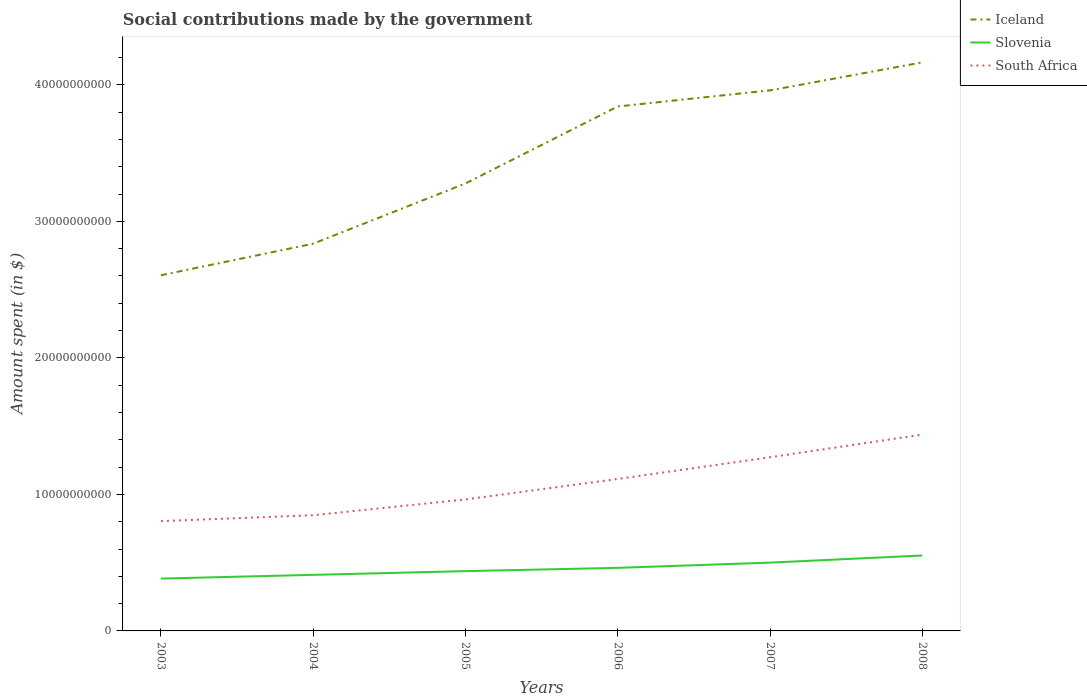Does the line corresponding to Slovenia intersect with the line corresponding to Iceland?
Make the answer very short. No. Across all years, what is the maximum amount spent on social contributions in Slovenia?
Provide a succinct answer. 3.83e+09. In which year was the amount spent on social contributions in South Africa maximum?
Keep it short and to the point. 2003. What is the total amount spent on social contributions in Slovenia in the graph?
Offer a terse response. -2.74e+08. What is the difference between the highest and the second highest amount spent on social contributions in Iceland?
Give a very brief answer. 1.56e+1. What is the difference between the highest and the lowest amount spent on social contributions in Iceland?
Give a very brief answer. 3. Is the amount spent on social contributions in Iceland strictly greater than the amount spent on social contributions in South Africa over the years?
Give a very brief answer. No. How many lines are there?
Ensure brevity in your answer.  3. How many years are there in the graph?
Make the answer very short. 6. Are the values on the major ticks of Y-axis written in scientific E-notation?
Your answer should be very brief. No. Does the graph contain any zero values?
Your answer should be very brief. No. How many legend labels are there?
Your answer should be very brief. 3. How are the legend labels stacked?
Provide a short and direct response. Vertical. What is the title of the graph?
Offer a very short reply. Social contributions made by the government. What is the label or title of the Y-axis?
Provide a succinct answer. Amount spent (in $). What is the Amount spent (in $) in Iceland in 2003?
Your response must be concise. 2.61e+1. What is the Amount spent (in $) of Slovenia in 2003?
Provide a short and direct response. 3.83e+09. What is the Amount spent (in $) in South Africa in 2003?
Offer a very short reply. 8.04e+09. What is the Amount spent (in $) of Iceland in 2004?
Make the answer very short. 2.84e+1. What is the Amount spent (in $) of Slovenia in 2004?
Give a very brief answer. 4.11e+09. What is the Amount spent (in $) in South Africa in 2004?
Your answer should be compact. 8.47e+09. What is the Amount spent (in $) in Iceland in 2005?
Offer a terse response. 3.28e+1. What is the Amount spent (in $) of Slovenia in 2005?
Your answer should be compact. 4.38e+09. What is the Amount spent (in $) of South Africa in 2005?
Your answer should be compact. 9.63e+09. What is the Amount spent (in $) in Iceland in 2006?
Make the answer very short. 3.84e+1. What is the Amount spent (in $) of Slovenia in 2006?
Ensure brevity in your answer.  4.62e+09. What is the Amount spent (in $) in South Africa in 2006?
Give a very brief answer. 1.11e+1. What is the Amount spent (in $) of Iceland in 2007?
Your answer should be compact. 3.96e+1. What is the Amount spent (in $) in Slovenia in 2007?
Offer a terse response. 5.00e+09. What is the Amount spent (in $) of South Africa in 2007?
Provide a succinct answer. 1.27e+1. What is the Amount spent (in $) in Iceland in 2008?
Provide a short and direct response. 4.16e+1. What is the Amount spent (in $) of Slovenia in 2008?
Keep it short and to the point. 5.53e+09. What is the Amount spent (in $) of South Africa in 2008?
Make the answer very short. 1.44e+1. Across all years, what is the maximum Amount spent (in $) of Iceland?
Ensure brevity in your answer.  4.16e+1. Across all years, what is the maximum Amount spent (in $) in Slovenia?
Make the answer very short. 5.53e+09. Across all years, what is the maximum Amount spent (in $) in South Africa?
Offer a very short reply. 1.44e+1. Across all years, what is the minimum Amount spent (in $) of Iceland?
Offer a terse response. 2.61e+1. Across all years, what is the minimum Amount spent (in $) of Slovenia?
Keep it short and to the point. 3.83e+09. Across all years, what is the minimum Amount spent (in $) of South Africa?
Your answer should be very brief. 8.04e+09. What is the total Amount spent (in $) of Iceland in the graph?
Ensure brevity in your answer.  2.07e+11. What is the total Amount spent (in $) of Slovenia in the graph?
Give a very brief answer. 2.75e+1. What is the total Amount spent (in $) in South Africa in the graph?
Ensure brevity in your answer.  6.44e+1. What is the difference between the Amount spent (in $) of Iceland in 2003 and that in 2004?
Make the answer very short. -2.31e+09. What is the difference between the Amount spent (in $) in Slovenia in 2003 and that in 2004?
Provide a short and direct response. -2.74e+08. What is the difference between the Amount spent (in $) of South Africa in 2003 and that in 2004?
Offer a terse response. -4.30e+08. What is the difference between the Amount spent (in $) in Iceland in 2003 and that in 2005?
Provide a short and direct response. -6.72e+09. What is the difference between the Amount spent (in $) of Slovenia in 2003 and that in 2005?
Give a very brief answer. -5.46e+08. What is the difference between the Amount spent (in $) in South Africa in 2003 and that in 2005?
Your response must be concise. -1.59e+09. What is the difference between the Amount spent (in $) in Iceland in 2003 and that in 2006?
Make the answer very short. -1.24e+1. What is the difference between the Amount spent (in $) in Slovenia in 2003 and that in 2006?
Offer a very short reply. -7.86e+08. What is the difference between the Amount spent (in $) in South Africa in 2003 and that in 2006?
Offer a very short reply. -3.09e+09. What is the difference between the Amount spent (in $) of Iceland in 2003 and that in 2007?
Your answer should be very brief. -1.35e+1. What is the difference between the Amount spent (in $) in Slovenia in 2003 and that in 2007?
Provide a succinct answer. -1.17e+09. What is the difference between the Amount spent (in $) in South Africa in 2003 and that in 2007?
Keep it short and to the point. -4.68e+09. What is the difference between the Amount spent (in $) of Iceland in 2003 and that in 2008?
Give a very brief answer. -1.56e+1. What is the difference between the Amount spent (in $) in Slovenia in 2003 and that in 2008?
Your answer should be compact. -1.69e+09. What is the difference between the Amount spent (in $) of South Africa in 2003 and that in 2008?
Provide a short and direct response. -6.34e+09. What is the difference between the Amount spent (in $) of Iceland in 2004 and that in 2005?
Offer a terse response. -4.41e+09. What is the difference between the Amount spent (in $) in Slovenia in 2004 and that in 2005?
Your answer should be compact. -2.72e+08. What is the difference between the Amount spent (in $) of South Africa in 2004 and that in 2005?
Ensure brevity in your answer.  -1.16e+09. What is the difference between the Amount spent (in $) in Iceland in 2004 and that in 2006?
Offer a very short reply. -1.01e+1. What is the difference between the Amount spent (in $) of Slovenia in 2004 and that in 2006?
Provide a short and direct response. -5.12e+08. What is the difference between the Amount spent (in $) of South Africa in 2004 and that in 2006?
Give a very brief answer. -2.66e+09. What is the difference between the Amount spent (in $) in Iceland in 2004 and that in 2007?
Ensure brevity in your answer.  -1.12e+1. What is the difference between the Amount spent (in $) in Slovenia in 2004 and that in 2007?
Ensure brevity in your answer.  -8.94e+08. What is the difference between the Amount spent (in $) of South Africa in 2004 and that in 2007?
Give a very brief answer. -4.25e+09. What is the difference between the Amount spent (in $) in Iceland in 2004 and that in 2008?
Provide a short and direct response. -1.33e+1. What is the difference between the Amount spent (in $) in Slovenia in 2004 and that in 2008?
Offer a terse response. -1.42e+09. What is the difference between the Amount spent (in $) in South Africa in 2004 and that in 2008?
Your response must be concise. -5.91e+09. What is the difference between the Amount spent (in $) of Iceland in 2005 and that in 2006?
Give a very brief answer. -5.64e+09. What is the difference between the Amount spent (in $) of Slovenia in 2005 and that in 2006?
Your answer should be very brief. -2.40e+08. What is the difference between the Amount spent (in $) in South Africa in 2005 and that in 2006?
Provide a short and direct response. -1.50e+09. What is the difference between the Amount spent (in $) of Iceland in 2005 and that in 2007?
Offer a very short reply. -6.82e+09. What is the difference between the Amount spent (in $) in Slovenia in 2005 and that in 2007?
Provide a succinct answer. -6.22e+08. What is the difference between the Amount spent (in $) in South Africa in 2005 and that in 2007?
Give a very brief answer. -3.09e+09. What is the difference between the Amount spent (in $) in Iceland in 2005 and that in 2008?
Offer a terse response. -8.87e+09. What is the difference between the Amount spent (in $) of Slovenia in 2005 and that in 2008?
Make the answer very short. -1.15e+09. What is the difference between the Amount spent (in $) in South Africa in 2005 and that in 2008?
Provide a short and direct response. -4.75e+09. What is the difference between the Amount spent (in $) of Iceland in 2006 and that in 2007?
Ensure brevity in your answer.  -1.18e+09. What is the difference between the Amount spent (in $) of Slovenia in 2006 and that in 2007?
Your response must be concise. -3.82e+08. What is the difference between the Amount spent (in $) of South Africa in 2006 and that in 2007?
Give a very brief answer. -1.59e+09. What is the difference between the Amount spent (in $) of Iceland in 2006 and that in 2008?
Your answer should be compact. -3.23e+09. What is the difference between the Amount spent (in $) in Slovenia in 2006 and that in 2008?
Provide a succinct answer. -9.06e+08. What is the difference between the Amount spent (in $) in South Africa in 2006 and that in 2008?
Your answer should be very brief. -3.25e+09. What is the difference between the Amount spent (in $) of Iceland in 2007 and that in 2008?
Offer a terse response. -2.05e+09. What is the difference between the Amount spent (in $) in Slovenia in 2007 and that in 2008?
Give a very brief answer. -5.23e+08. What is the difference between the Amount spent (in $) in South Africa in 2007 and that in 2008?
Your answer should be very brief. -1.66e+09. What is the difference between the Amount spent (in $) in Iceland in 2003 and the Amount spent (in $) in Slovenia in 2004?
Your response must be concise. 2.19e+1. What is the difference between the Amount spent (in $) in Iceland in 2003 and the Amount spent (in $) in South Africa in 2004?
Offer a terse response. 1.76e+1. What is the difference between the Amount spent (in $) in Slovenia in 2003 and the Amount spent (in $) in South Africa in 2004?
Your response must be concise. -4.64e+09. What is the difference between the Amount spent (in $) of Iceland in 2003 and the Amount spent (in $) of Slovenia in 2005?
Your response must be concise. 2.17e+1. What is the difference between the Amount spent (in $) in Iceland in 2003 and the Amount spent (in $) in South Africa in 2005?
Offer a terse response. 1.64e+1. What is the difference between the Amount spent (in $) of Slovenia in 2003 and the Amount spent (in $) of South Africa in 2005?
Your answer should be compact. -5.80e+09. What is the difference between the Amount spent (in $) of Iceland in 2003 and the Amount spent (in $) of Slovenia in 2006?
Offer a very short reply. 2.14e+1. What is the difference between the Amount spent (in $) of Iceland in 2003 and the Amount spent (in $) of South Africa in 2006?
Your response must be concise. 1.49e+1. What is the difference between the Amount spent (in $) in Slovenia in 2003 and the Amount spent (in $) in South Africa in 2006?
Ensure brevity in your answer.  -7.30e+09. What is the difference between the Amount spent (in $) of Iceland in 2003 and the Amount spent (in $) of Slovenia in 2007?
Give a very brief answer. 2.11e+1. What is the difference between the Amount spent (in $) in Iceland in 2003 and the Amount spent (in $) in South Africa in 2007?
Your answer should be very brief. 1.33e+1. What is the difference between the Amount spent (in $) in Slovenia in 2003 and the Amount spent (in $) in South Africa in 2007?
Offer a terse response. -8.89e+09. What is the difference between the Amount spent (in $) of Iceland in 2003 and the Amount spent (in $) of Slovenia in 2008?
Your answer should be compact. 2.05e+1. What is the difference between the Amount spent (in $) of Iceland in 2003 and the Amount spent (in $) of South Africa in 2008?
Offer a terse response. 1.17e+1. What is the difference between the Amount spent (in $) in Slovenia in 2003 and the Amount spent (in $) in South Africa in 2008?
Give a very brief answer. -1.05e+1. What is the difference between the Amount spent (in $) of Iceland in 2004 and the Amount spent (in $) of Slovenia in 2005?
Offer a very short reply. 2.40e+1. What is the difference between the Amount spent (in $) of Iceland in 2004 and the Amount spent (in $) of South Africa in 2005?
Keep it short and to the point. 1.87e+1. What is the difference between the Amount spent (in $) in Slovenia in 2004 and the Amount spent (in $) in South Africa in 2005?
Your response must be concise. -5.53e+09. What is the difference between the Amount spent (in $) of Iceland in 2004 and the Amount spent (in $) of Slovenia in 2006?
Offer a very short reply. 2.37e+1. What is the difference between the Amount spent (in $) in Iceland in 2004 and the Amount spent (in $) in South Africa in 2006?
Your response must be concise. 1.72e+1. What is the difference between the Amount spent (in $) of Slovenia in 2004 and the Amount spent (in $) of South Africa in 2006?
Give a very brief answer. -7.02e+09. What is the difference between the Amount spent (in $) of Iceland in 2004 and the Amount spent (in $) of Slovenia in 2007?
Your answer should be very brief. 2.34e+1. What is the difference between the Amount spent (in $) of Iceland in 2004 and the Amount spent (in $) of South Africa in 2007?
Your answer should be very brief. 1.56e+1. What is the difference between the Amount spent (in $) in Slovenia in 2004 and the Amount spent (in $) in South Africa in 2007?
Provide a short and direct response. -8.61e+09. What is the difference between the Amount spent (in $) in Iceland in 2004 and the Amount spent (in $) in Slovenia in 2008?
Ensure brevity in your answer.  2.28e+1. What is the difference between the Amount spent (in $) in Iceland in 2004 and the Amount spent (in $) in South Africa in 2008?
Offer a very short reply. 1.40e+1. What is the difference between the Amount spent (in $) of Slovenia in 2004 and the Amount spent (in $) of South Africa in 2008?
Offer a terse response. -1.03e+1. What is the difference between the Amount spent (in $) of Iceland in 2005 and the Amount spent (in $) of Slovenia in 2006?
Offer a terse response. 2.82e+1. What is the difference between the Amount spent (in $) in Iceland in 2005 and the Amount spent (in $) in South Africa in 2006?
Keep it short and to the point. 2.16e+1. What is the difference between the Amount spent (in $) in Slovenia in 2005 and the Amount spent (in $) in South Africa in 2006?
Offer a very short reply. -6.75e+09. What is the difference between the Amount spent (in $) of Iceland in 2005 and the Amount spent (in $) of Slovenia in 2007?
Ensure brevity in your answer.  2.78e+1. What is the difference between the Amount spent (in $) in Iceland in 2005 and the Amount spent (in $) in South Africa in 2007?
Your response must be concise. 2.01e+1. What is the difference between the Amount spent (in $) of Slovenia in 2005 and the Amount spent (in $) of South Africa in 2007?
Your response must be concise. -8.34e+09. What is the difference between the Amount spent (in $) in Iceland in 2005 and the Amount spent (in $) in Slovenia in 2008?
Make the answer very short. 2.73e+1. What is the difference between the Amount spent (in $) in Iceland in 2005 and the Amount spent (in $) in South Africa in 2008?
Keep it short and to the point. 1.84e+1. What is the difference between the Amount spent (in $) in Slovenia in 2005 and the Amount spent (in $) in South Africa in 2008?
Provide a short and direct response. -1.00e+1. What is the difference between the Amount spent (in $) of Iceland in 2006 and the Amount spent (in $) of Slovenia in 2007?
Keep it short and to the point. 3.34e+1. What is the difference between the Amount spent (in $) in Iceland in 2006 and the Amount spent (in $) in South Africa in 2007?
Offer a terse response. 2.57e+1. What is the difference between the Amount spent (in $) of Slovenia in 2006 and the Amount spent (in $) of South Africa in 2007?
Your response must be concise. -8.10e+09. What is the difference between the Amount spent (in $) of Iceland in 2006 and the Amount spent (in $) of Slovenia in 2008?
Provide a short and direct response. 3.29e+1. What is the difference between the Amount spent (in $) of Iceland in 2006 and the Amount spent (in $) of South Africa in 2008?
Keep it short and to the point. 2.40e+1. What is the difference between the Amount spent (in $) of Slovenia in 2006 and the Amount spent (in $) of South Africa in 2008?
Your response must be concise. -9.76e+09. What is the difference between the Amount spent (in $) in Iceland in 2007 and the Amount spent (in $) in Slovenia in 2008?
Provide a short and direct response. 3.41e+1. What is the difference between the Amount spent (in $) of Iceland in 2007 and the Amount spent (in $) of South Africa in 2008?
Offer a terse response. 2.52e+1. What is the difference between the Amount spent (in $) of Slovenia in 2007 and the Amount spent (in $) of South Africa in 2008?
Offer a very short reply. -9.38e+09. What is the average Amount spent (in $) in Iceland per year?
Provide a short and direct response. 3.45e+1. What is the average Amount spent (in $) of Slovenia per year?
Your answer should be compact. 4.58e+09. What is the average Amount spent (in $) of South Africa per year?
Ensure brevity in your answer.  1.07e+1. In the year 2003, what is the difference between the Amount spent (in $) in Iceland and Amount spent (in $) in Slovenia?
Provide a short and direct response. 2.22e+1. In the year 2003, what is the difference between the Amount spent (in $) of Iceland and Amount spent (in $) of South Africa?
Provide a succinct answer. 1.80e+1. In the year 2003, what is the difference between the Amount spent (in $) of Slovenia and Amount spent (in $) of South Africa?
Provide a succinct answer. -4.21e+09. In the year 2004, what is the difference between the Amount spent (in $) in Iceland and Amount spent (in $) in Slovenia?
Keep it short and to the point. 2.43e+1. In the year 2004, what is the difference between the Amount spent (in $) of Iceland and Amount spent (in $) of South Africa?
Your response must be concise. 1.99e+1. In the year 2004, what is the difference between the Amount spent (in $) in Slovenia and Amount spent (in $) in South Africa?
Offer a terse response. -4.37e+09. In the year 2005, what is the difference between the Amount spent (in $) of Iceland and Amount spent (in $) of Slovenia?
Provide a short and direct response. 2.84e+1. In the year 2005, what is the difference between the Amount spent (in $) in Iceland and Amount spent (in $) in South Africa?
Provide a succinct answer. 2.31e+1. In the year 2005, what is the difference between the Amount spent (in $) in Slovenia and Amount spent (in $) in South Africa?
Your answer should be very brief. -5.25e+09. In the year 2006, what is the difference between the Amount spent (in $) in Iceland and Amount spent (in $) in Slovenia?
Your answer should be very brief. 3.38e+1. In the year 2006, what is the difference between the Amount spent (in $) of Iceland and Amount spent (in $) of South Africa?
Your answer should be very brief. 2.73e+1. In the year 2006, what is the difference between the Amount spent (in $) in Slovenia and Amount spent (in $) in South Africa?
Ensure brevity in your answer.  -6.51e+09. In the year 2007, what is the difference between the Amount spent (in $) of Iceland and Amount spent (in $) of Slovenia?
Make the answer very short. 3.46e+1. In the year 2007, what is the difference between the Amount spent (in $) in Iceland and Amount spent (in $) in South Africa?
Your answer should be very brief. 2.69e+1. In the year 2007, what is the difference between the Amount spent (in $) of Slovenia and Amount spent (in $) of South Africa?
Make the answer very short. -7.72e+09. In the year 2008, what is the difference between the Amount spent (in $) in Iceland and Amount spent (in $) in Slovenia?
Keep it short and to the point. 3.61e+1. In the year 2008, what is the difference between the Amount spent (in $) in Iceland and Amount spent (in $) in South Africa?
Keep it short and to the point. 2.73e+1. In the year 2008, what is the difference between the Amount spent (in $) in Slovenia and Amount spent (in $) in South Africa?
Offer a very short reply. -8.85e+09. What is the ratio of the Amount spent (in $) of Iceland in 2003 to that in 2004?
Ensure brevity in your answer.  0.92. What is the ratio of the Amount spent (in $) of South Africa in 2003 to that in 2004?
Ensure brevity in your answer.  0.95. What is the ratio of the Amount spent (in $) of Iceland in 2003 to that in 2005?
Make the answer very short. 0.79. What is the ratio of the Amount spent (in $) of Slovenia in 2003 to that in 2005?
Your answer should be very brief. 0.88. What is the ratio of the Amount spent (in $) in South Africa in 2003 to that in 2005?
Give a very brief answer. 0.83. What is the ratio of the Amount spent (in $) of Iceland in 2003 to that in 2006?
Your answer should be very brief. 0.68. What is the ratio of the Amount spent (in $) in Slovenia in 2003 to that in 2006?
Keep it short and to the point. 0.83. What is the ratio of the Amount spent (in $) of South Africa in 2003 to that in 2006?
Your answer should be compact. 0.72. What is the ratio of the Amount spent (in $) in Iceland in 2003 to that in 2007?
Give a very brief answer. 0.66. What is the ratio of the Amount spent (in $) of Slovenia in 2003 to that in 2007?
Ensure brevity in your answer.  0.77. What is the ratio of the Amount spent (in $) of South Africa in 2003 to that in 2007?
Your answer should be very brief. 0.63. What is the ratio of the Amount spent (in $) of Iceland in 2003 to that in 2008?
Keep it short and to the point. 0.63. What is the ratio of the Amount spent (in $) of Slovenia in 2003 to that in 2008?
Your answer should be very brief. 0.69. What is the ratio of the Amount spent (in $) of South Africa in 2003 to that in 2008?
Offer a terse response. 0.56. What is the ratio of the Amount spent (in $) of Iceland in 2004 to that in 2005?
Offer a terse response. 0.87. What is the ratio of the Amount spent (in $) of Slovenia in 2004 to that in 2005?
Make the answer very short. 0.94. What is the ratio of the Amount spent (in $) of South Africa in 2004 to that in 2005?
Make the answer very short. 0.88. What is the ratio of the Amount spent (in $) in Iceland in 2004 to that in 2006?
Your response must be concise. 0.74. What is the ratio of the Amount spent (in $) in Slovenia in 2004 to that in 2006?
Your answer should be very brief. 0.89. What is the ratio of the Amount spent (in $) of South Africa in 2004 to that in 2006?
Provide a short and direct response. 0.76. What is the ratio of the Amount spent (in $) in Iceland in 2004 to that in 2007?
Give a very brief answer. 0.72. What is the ratio of the Amount spent (in $) in Slovenia in 2004 to that in 2007?
Your answer should be very brief. 0.82. What is the ratio of the Amount spent (in $) in South Africa in 2004 to that in 2007?
Make the answer very short. 0.67. What is the ratio of the Amount spent (in $) in Iceland in 2004 to that in 2008?
Ensure brevity in your answer.  0.68. What is the ratio of the Amount spent (in $) in Slovenia in 2004 to that in 2008?
Ensure brevity in your answer.  0.74. What is the ratio of the Amount spent (in $) in South Africa in 2004 to that in 2008?
Keep it short and to the point. 0.59. What is the ratio of the Amount spent (in $) of Iceland in 2005 to that in 2006?
Give a very brief answer. 0.85. What is the ratio of the Amount spent (in $) of Slovenia in 2005 to that in 2006?
Provide a short and direct response. 0.95. What is the ratio of the Amount spent (in $) of South Africa in 2005 to that in 2006?
Your response must be concise. 0.87. What is the ratio of the Amount spent (in $) of Iceland in 2005 to that in 2007?
Provide a short and direct response. 0.83. What is the ratio of the Amount spent (in $) in Slovenia in 2005 to that in 2007?
Offer a very short reply. 0.88. What is the ratio of the Amount spent (in $) of South Africa in 2005 to that in 2007?
Offer a very short reply. 0.76. What is the ratio of the Amount spent (in $) in Iceland in 2005 to that in 2008?
Your answer should be very brief. 0.79. What is the ratio of the Amount spent (in $) of Slovenia in 2005 to that in 2008?
Give a very brief answer. 0.79. What is the ratio of the Amount spent (in $) in South Africa in 2005 to that in 2008?
Provide a succinct answer. 0.67. What is the ratio of the Amount spent (in $) of Iceland in 2006 to that in 2007?
Your answer should be compact. 0.97. What is the ratio of the Amount spent (in $) of Slovenia in 2006 to that in 2007?
Offer a very short reply. 0.92. What is the ratio of the Amount spent (in $) of South Africa in 2006 to that in 2007?
Ensure brevity in your answer.  0.87. What is the ratio of the Amount spent (in $) in Iceland in 2006 to that in 2008?
Offer a very short reply. 0.92. What is the ratio of the Amount spent (in $) of Slovenia in 2006 to that in 2008?
Keep it short and to the point. 0.84. What is the ratio of the Amount spent (in $) in South Africa in 2006 to that in 2008?
Your answer should be compact. 0.77. What is the ratio of the Amount spent (in $) in Iceland in 2007 to that in 2008?
Your answer should be very brief. 0.95. What is the ratio of the Amount spent (in $) in Slovenia in 2007 to that in 2008?
Provide a succinct answer. 0.91. What is the ratio of the Amount spent (in $) of South Africa in 2007 to that in 2008?
Offer a terse response. 0.88. What is the difference between the highest and the second highest Amount spent (in $) of Iceland?
Give a very brief answer. 2.05e+09. What is the difference between the highest and the second highest Amount spent (in $) in Slovenia?
Give a very brief answer. 5.23e+08. What is the difference between the highest and the second highest Amount spent (in $) of South Africa?
Your answer should be compact. 1.66e+09. What is the difference between the highest and the lowest Amount spent (in $) in Iceland?
Ensure brevity in your answer.  1.56e+1. What is the difference between the highest and the lowest Amount spent (in $) of Slovenia?
Your response must be concise. 1.69e+09. What is the difference between the highest and the lowest Amount spent (in $) in South Africa?
Your answer should be compact. 6.34e+09. 